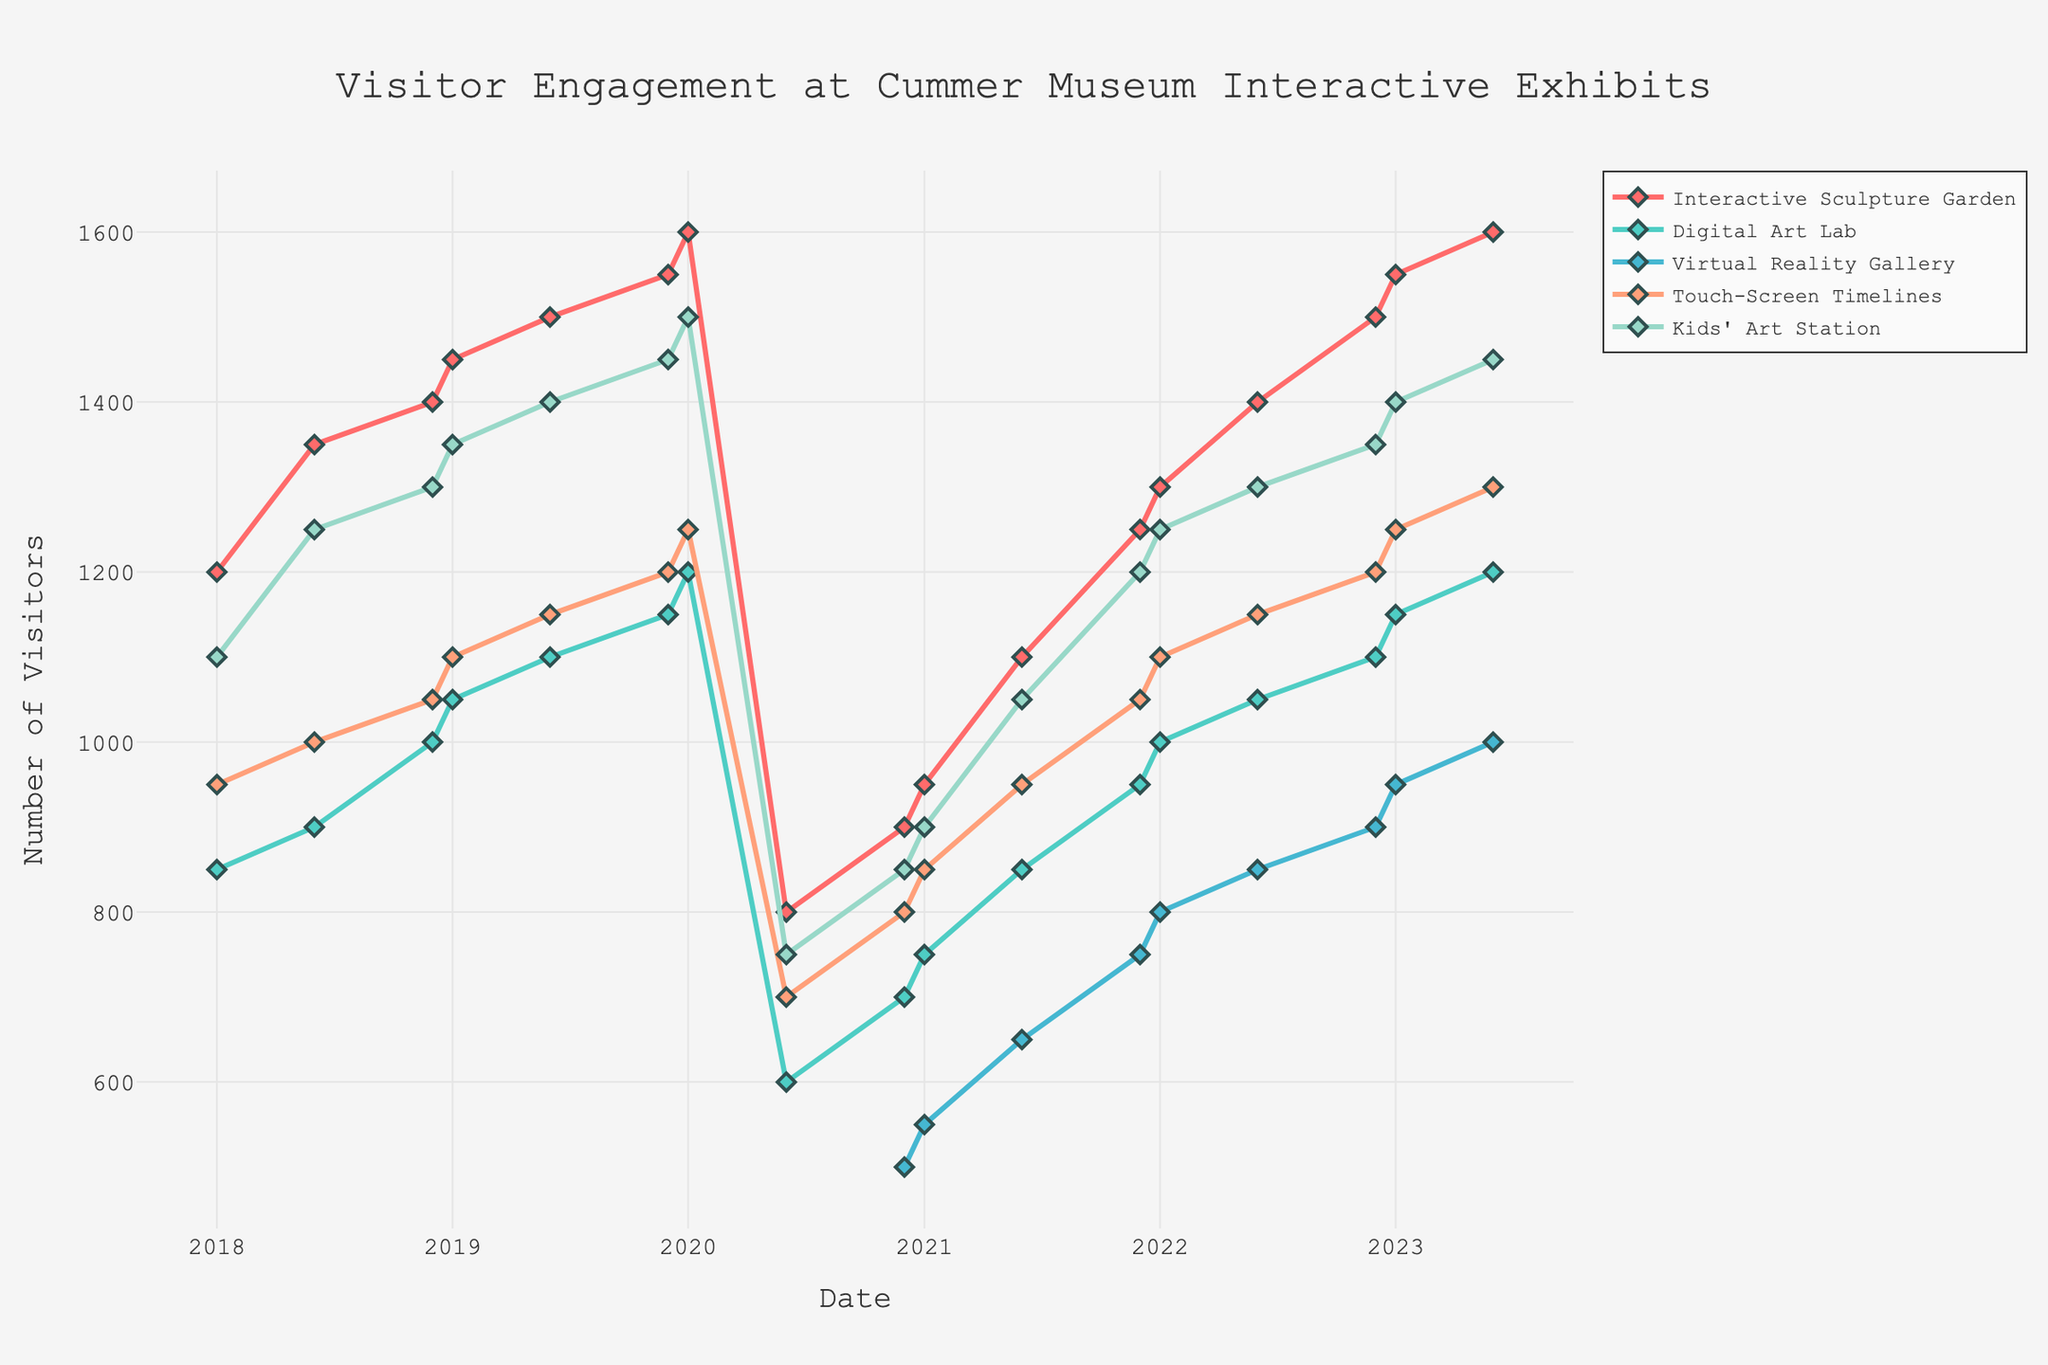How does visitor engagement for the Interactive Sculpture Garden compare between January 2018 and June 2023? To find this, look at the visitor numbers for the Interactive Sculpture Garden in January 2018 and June 2023. January 2018 has 1200 visitors, and June 2023 has 1600 visitors. The comparison shows an increase of 400 visitors over this period.
Answer: Increased by 400 Which exhibit had the highest engagement in June 2023? In June 2023, the visitor numbers for the exhibits are: Interactive Sculpture Garden 1600, Digital Art Lab 1200, Virtual Reality Gallery 1000, Touch-Screen Timelines 1300, and Kids' Art Station 1450. The Interactive Sculpture Garden had the highest engagement with 1600 visitors.
Answer: Interactive Sculpture Garden When did the Virtual Reality Gallery first appear in the data set? Look at the data timeline for the Virtual Reality Gallery. It first appears with visitor numbers in December 2020, with 500 visitors.
Answer: December 2020 What is the total number of visitors for the Kids' Art Station in all reported months of 2022? Add the visitor numbers for the Kids' Art Station for January 2022, June 2022, and December 2022. These numbers are 1250, 1300, and 1350 respectively. The total is 1250 + 1300 + 1350 = 3900.
Answer: 3900 How did the visitor engagement for the Digital Art Lab change from January 2020 to June 2020? Check the visitor numbers for the Digital Art Lab in January 2020 (1200 visitors) and June 2020 (600 visitors). The engagement dropped by 600 visitors.
Answer: Decreased by 600 Which exhibit had the most significant drop during June 2020? Compare the visitor numbers in January 2020 and June 2020 for all exhibits: Interactive Sculpture Garden (1600 to 800), Digital Art Lab (1200 to 600), Virtual Reality Gallery (N/A), Touch-Screen Timelines (1250 to 700), Kids' Art Station (1500 to 750). The Interactive Sculpture Garden had the most significant drop by 800 visitors.
Answer: Interactive Sculpture Garden Among all exhibits, which one had the most steady increase over the 5 years? Examine the trends for all exhibits and determine which show a mostly consistent upward trend. The Kids' Art Station shows a steady increase from 1100 visitors in January 2018 to 1450 visitors in June 2023.
Answer: Kids' Art Station What was the highest visitor engagement for the Touch-Screen Timelines, and when did it occur? Review the highest data point for the Touch-Screen Timelines. The highest engagement occurs in June 2023 with 1300 visitors.
Answer: June 2023 What is the average visitor count for the Virtual Reality Gallery from its inception until June 2023? Sum the visitor numbers for the Virtual Reality Gallery (500 in Dec 2020, 550 in Jan 2021, 650 in June 2021, 750 in Dec 2021, 800 in Jan 2022, 850 in June 2022, 900 in Dec 2022, 950 in Jan 2023, 1000 in June 2023), which equals 6500. Divide by the number of periods (9). 6500 / 9 ≈ 722.
Answer: Approximately 722 By what percentage did the Kids' Art Station visitor numbers recover from June 2020 to January 2021? Calculate the percentage increase from 750 visitors in June 2020 to 900 visitors in January 2021. The increase is 900 - 750 = 150. The percentage change is (150 / 750) * 100 ≈ 20%.
Answer: 20% 